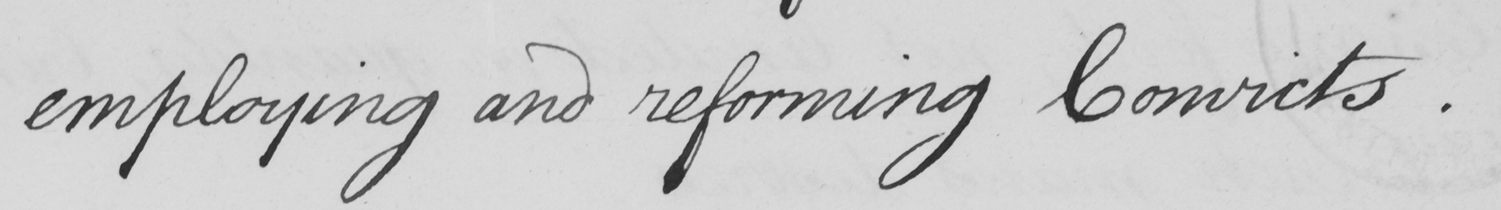Transcribe the text shown in this historical manuscript line. employing and reforming Convicts . 